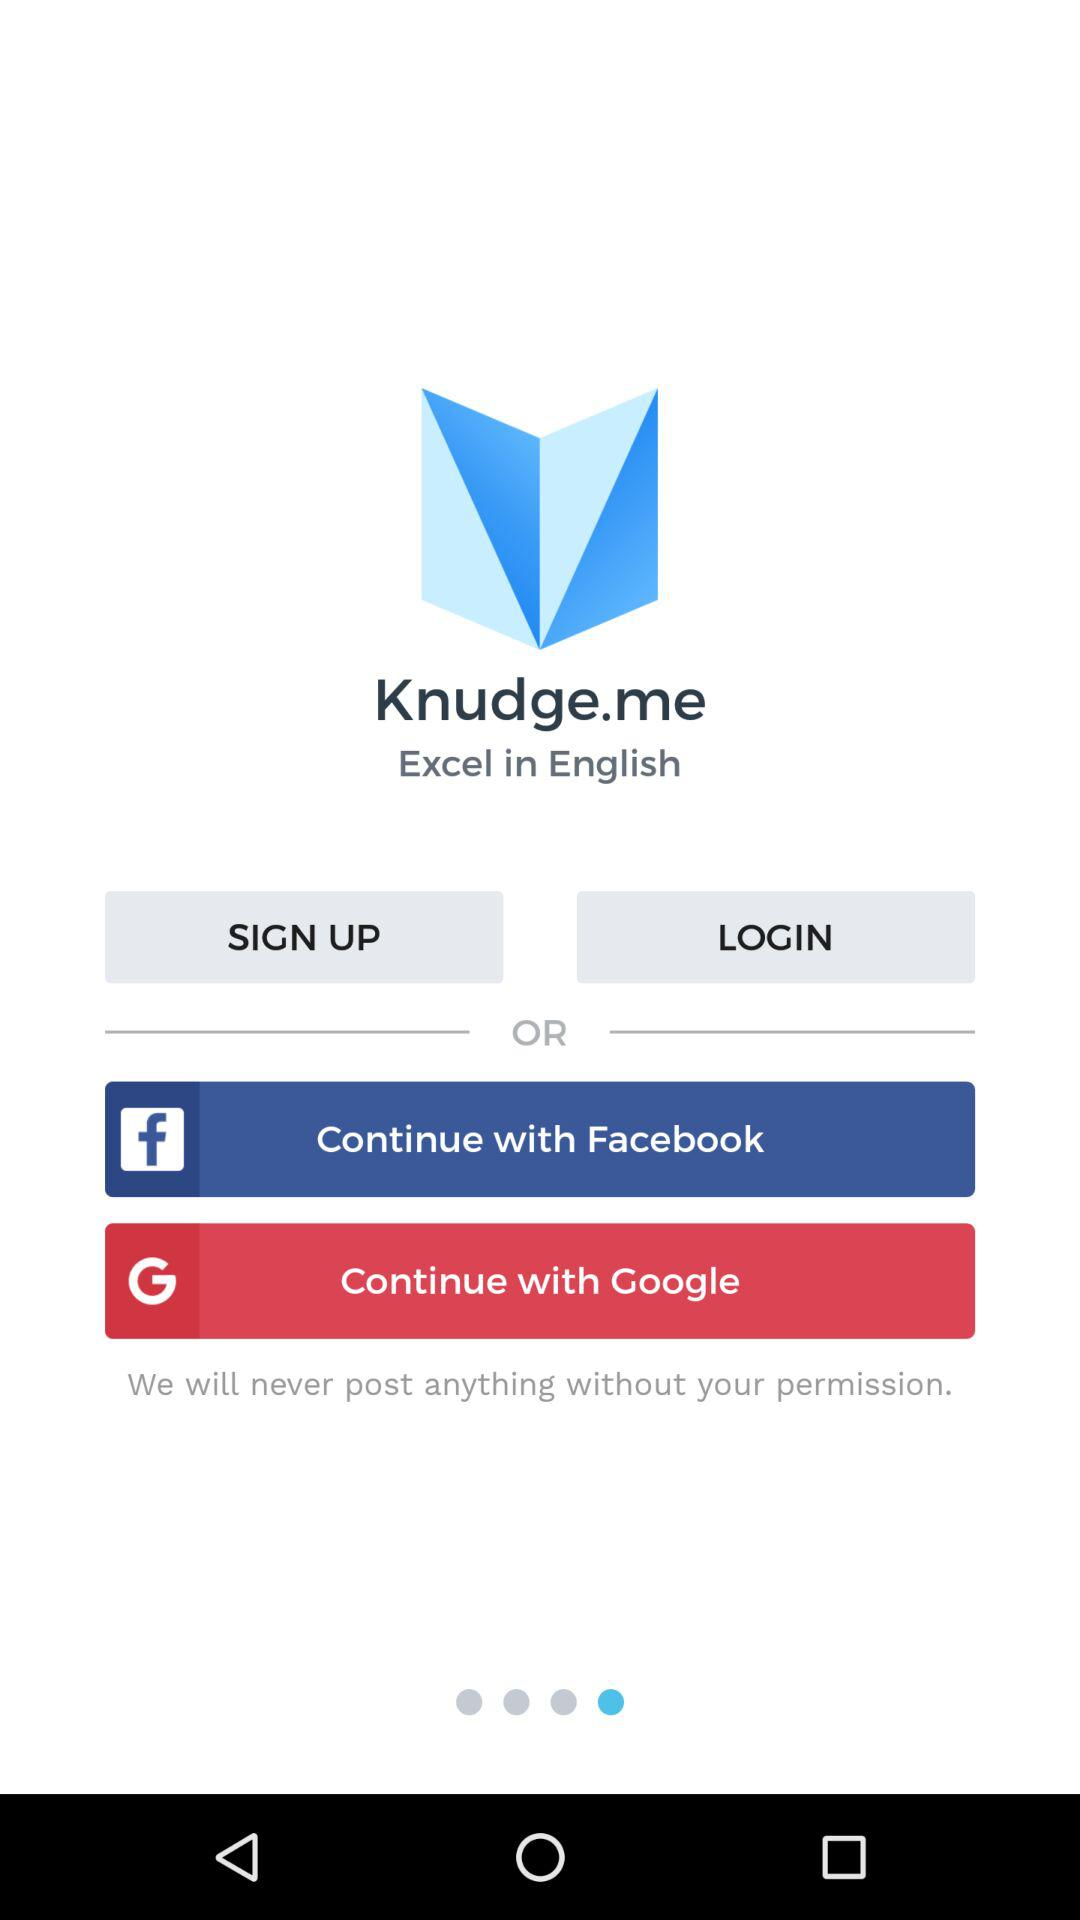What accounts can I use to sign up? You can sign up with "Facebook" and "Google". 